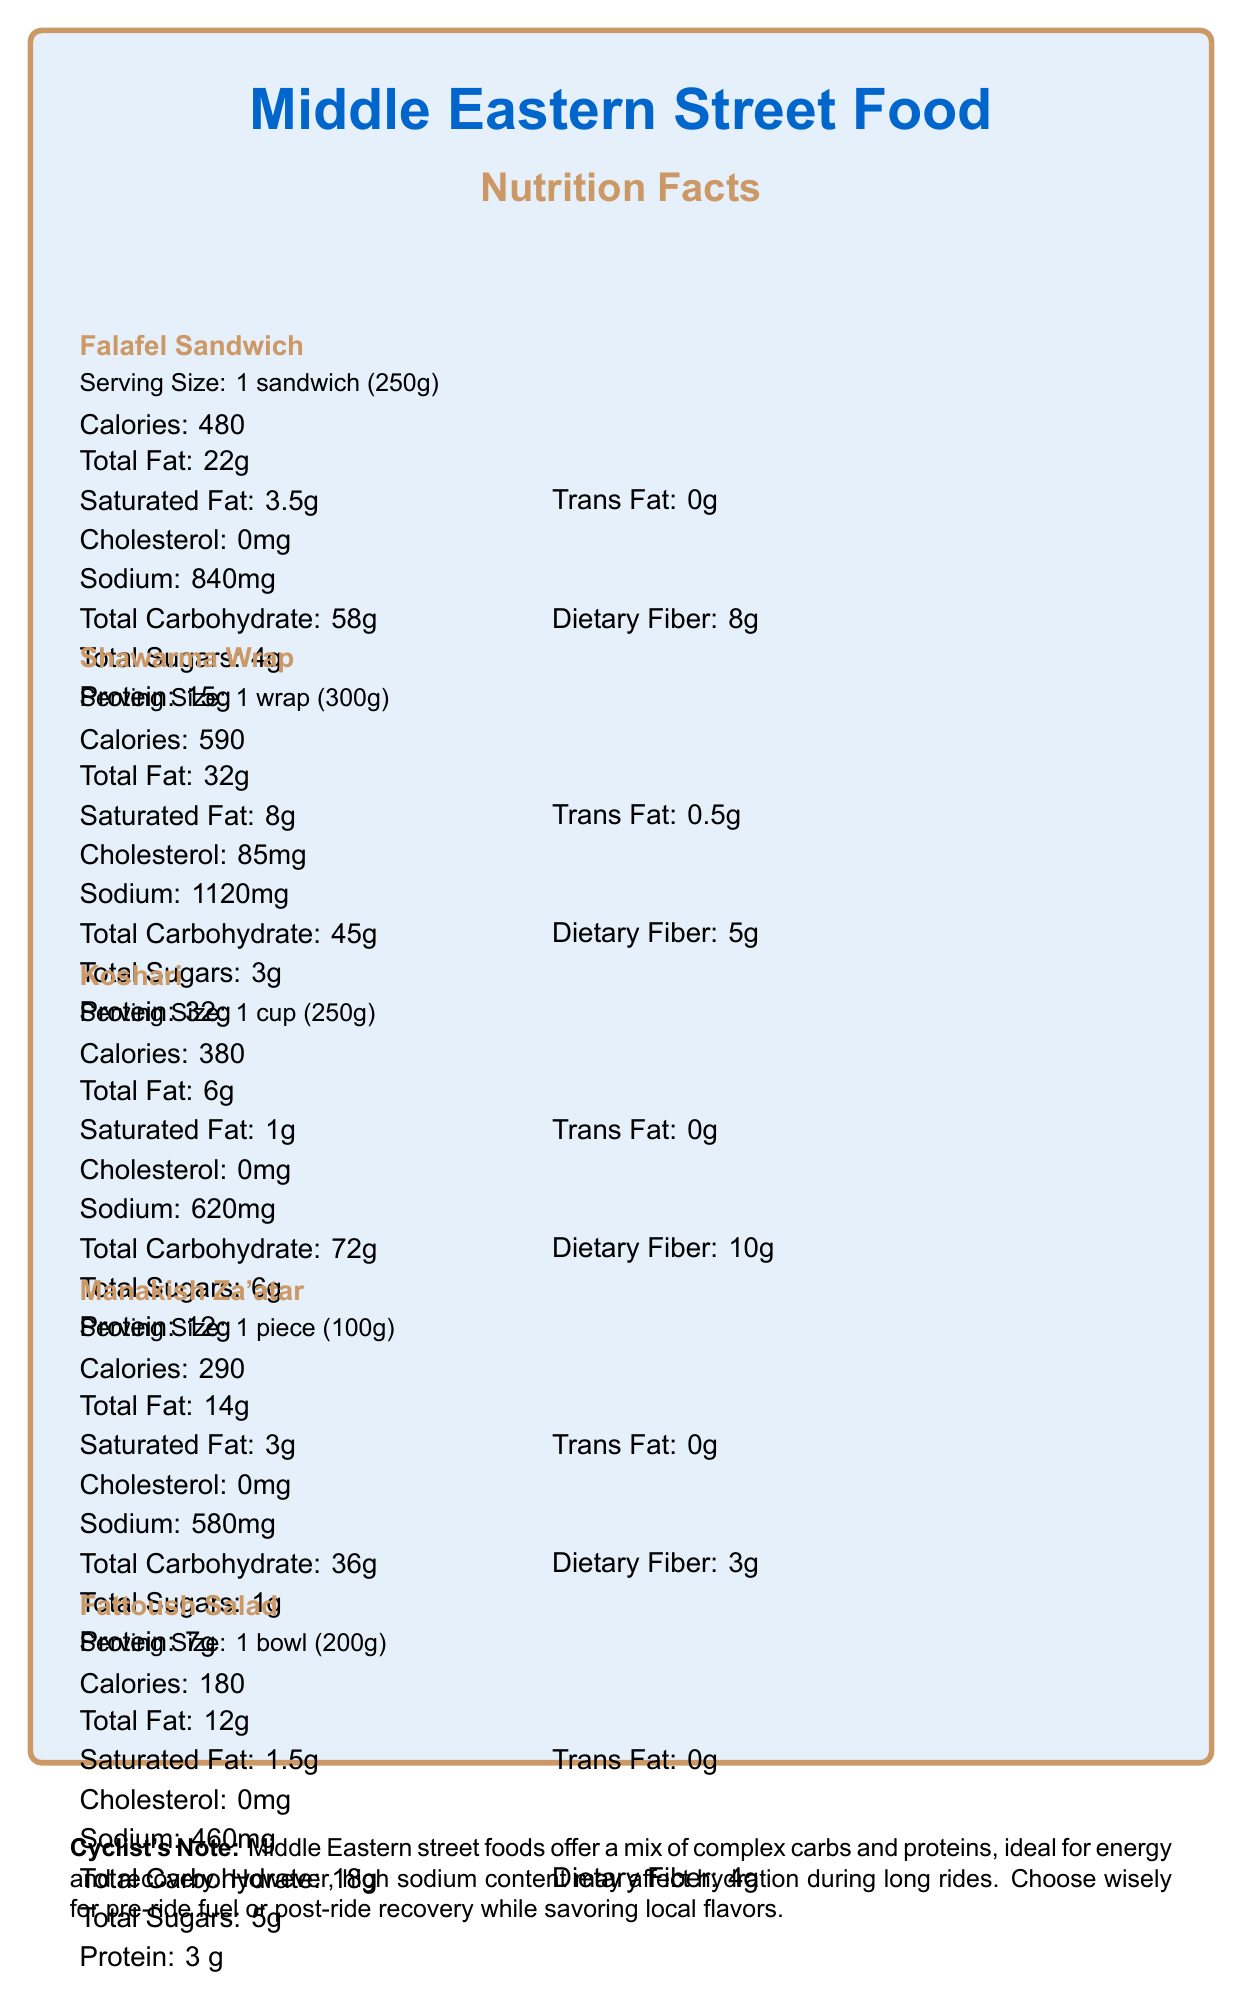What is the calorie content of a Falafel Sandwich? The document states that a Falafel Sandwich contains 480 calories in a serving size of 1 sandwich (250g).
Answer: 480 calories How much sodium is in a Shawarma Wrap? The document indicates that a Shawarma Wrap contains 1120 mg of sodium in a serving size of 1 wrap (300g).
Answer: 1120 mg What is the serving size of Koshari? According to the document, the serving size of Koshari is 1 cup (250g).
Answer: 1 cup (250g) How many grams of protein are in a piece of Manakish Za'atar? The document shows that a piece of Manakish Za'atar contains 7 grams of protein.
Answer: 7 grams How much dietary fiber does a Fattoush Salad provide? The document lists the dietary fiber content of a Fattoush Salad as 4 grams per bowl (200g).
Answer: 4 grams Which food has the highest calorie content? 
A) Falafel Sandwich 
B) Shawarma Wrap 
C) Koshari 
D) Manakish Za'atar 
E) Fattoush Salad The calorie content for each food is as follows: Falafel Sandwich (480), Shawarma Wrap (590), Koshari (380), Manakish Za'atar (290), Fattoush Salad (180). The Shawarma Wrap has the highest calorie content.
Answer: B) Shawarma Wrap Which food has the lowest sodium content? 
1) Falafel Sandwich 
2) Shawarma Wrap 
3) Koshari 
4) Manakish Za'atar 
5) Fattoush Salad The sodium content for each food is: Falafel Sandwich (840 mg), Shawarma Wrap (1120 mg), Koshari (620 mg), Manakish Za'atar (580 mg), Fattoush Salad (460 mg). The Fattoush Salad has the lowest sodium content.
Answer: 5) Fattoush Salad Is the total fat content in Koshari higher than in Manakish Za'atar? The total fat content in Koshari is 6 grams, whereas it is 14 grams in Manakish Za'atar, making Manakish Za'atar higher in total fat content.
Answer: No Summarize the main idea of the document. The document aims to inform readers about the nutritional values of Middle Eastern street foods and provide context on their health, cultural, and political implications, especially relevant to cyclists.
Answer: The document provides detailed nutritional information for popular Middle Eastern street foods: Falafel Sandwich, Shawarma Wrap, Koshari, Manakish Za'atar, and Fattoush Salad. It highlights their calorie, fat, sodium, carbohydrate, protein, and other nutrient contents while offering insights into their health impacts for cyclists and the broader cultural and socio-economic implications of street food in the region. What is the main ingredient in Falafel? The document does not provide information about the main ingredients of the foods listed, only their nutritional content.
Answer: Cannot be determined Comparing Shawarma Wrap and Falafel Sandwich, which one has more protein? The document states that a Shawarma Wrap contains 32 grams of protein, while a Falafel Sandwich contains 15 grams of protein. Therefore, the Shawarma Wrap has more protein.
Answer: Shawarma Wrap Which of the listed street foods has the highest amount of dietary fiber? The document indicates that Koshari contains 10 grams of dietary fiber, the highest among the listed foods: Falafel Sandwich (8g), Shawarma Wrap (5g), Manakish Za'atar (3g), and Fattoush Salad (4g).
Answer: Koshari How should a cyclist use the information in the document when choosing street food for a pre-ride meal? The document highlights that Middle Eastern street foods offer a mix of complex carbs and proteins, ideal for energy and muscle recovery, but the high sodium content might affect hydration necessary for long rides.
Answer: They should look for foods high in complex carbohydrates and proteins but be cautious of high sodium levels which can affect hydration. 